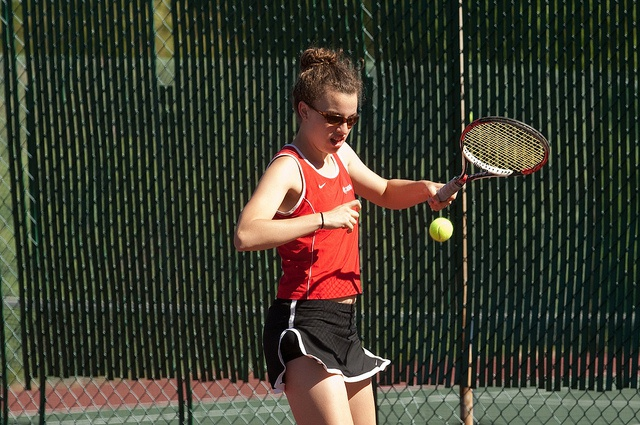Describe the objects in this image and their specific colors. I can see people in gray, maroon, black, ivory, and salmon tones, tennis racket in gray, black, tan, and maroon tones, and sports ball in gray, khaki, olive, and beige tones in this image. 